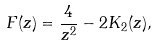Convert formula to latex. <formula><loc_0><loc_0><loc_500><loc_500>F ( z ) = \frac { 4 } { z ^ { 2 } } - 2 K _ { 2 } ( z ) ,</formula> 